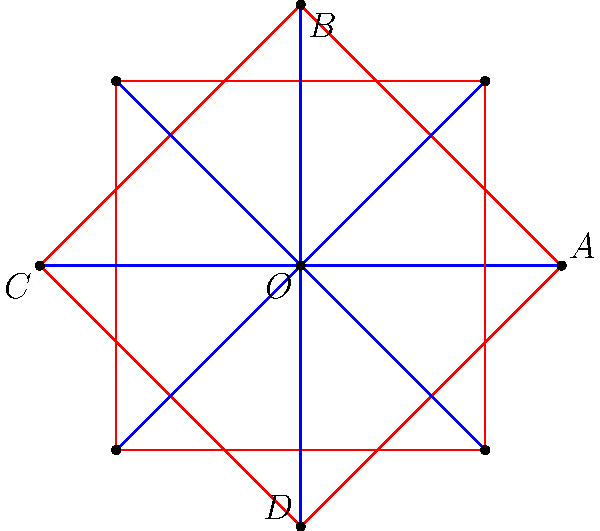In this Islamic geometric art pattern, an 8-pointed star is formed. If angle $\angle AOB$ is 90°, what is the measure of angle $\angle ADB$? Let's approach this step-by-step:

1) In a regular 8-pointed star, the central angles are all equal. Since there are 8 points, each central angle measures:
   $$\frac{360°}{8} = 45°$$

2) We're given that $\angle AOB = 90°$. This means it spans two central angles.

3) In the triangle $\triangle AOD$:
   - $\angle AOD = 135°$ (three central angles)
   - $OA = OD$ (radii of the circle)
   - Therefore, $\triangle AOD$ is isosceles, and $\angle OAD = \angle ODA$

4) Let's call the measure of $\angle OAD$ as $x$. Then:
   $$x + x + 135° = 180°$$ (sum of angles in a triangle)
   $$2x = 45°$$
   $$x = 22.5°$$

5) So, $\angle OAD = \angle ODA = 22.5°$

6) Now, in $\triangle ADB$:
   - $\angle BAD = 90° - 22.5° = 67.5°$ (exterior angle of $\triangle AOD$)
   - $\angle ABD = 67.5°$ (the star is symmetric)
   - Therefore, $\angle ADB = 180° - 67.5° - 67.5° = 45°$

Thus, the measure of $\angle ADB$ is 45°.
Answer: 45° 